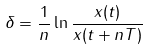<formula> <loc_0><loc_0><loc_500><loc_500>\delta = \frac { 1 } { n } \ln \frac { x ( t ) } { x ( t + n T ) }</formula> 